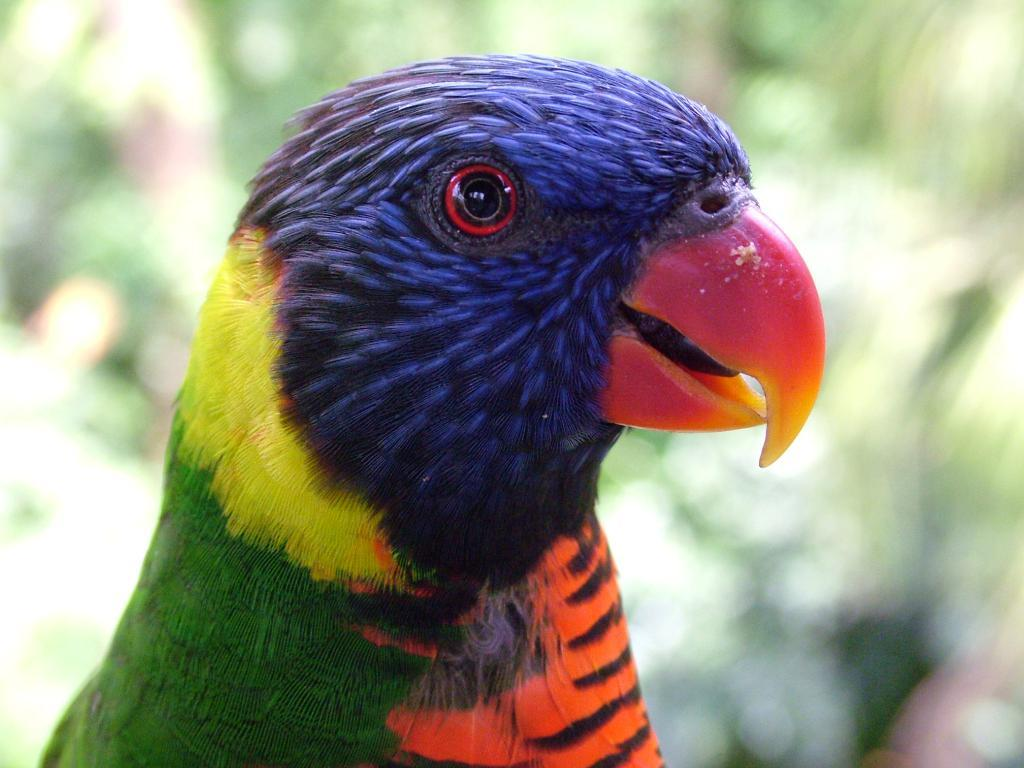What type of animal can be seen in the image? There is a bird in the image. What is the bird's annual income in the image? There is no information about the bird's income in the image, as birds do not have incomes. 